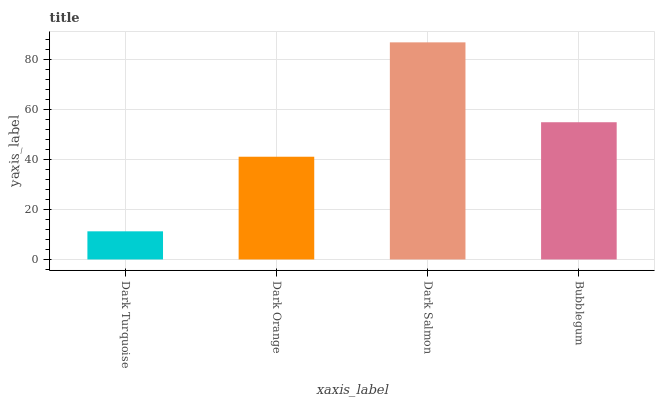Is Dark Turquoise the minimum?
Answer yes or no. Yes. Is Dark Salmon the maximum?
Answer yes or no. Yes. Is Dark Orange the minimum?
Answer yes or no. No. Is Dark Orange the maximum?
Answer yes or no. No. Is Dark Orange greater than Dark Turquoise?
Answer yes or no. Yes. Is Dark Turquoise less than Dark Orange?
Answer yes or no. Yes. Is Dark Turquoise greater than Dark Orange?
Answer yes or no. No. Is Dark Orange less than Dark Turquoise?
Answer yes or no. No. Is Bubblegum the high median?
Answer yes or no. Yes. Is Dark Orange the low median?
Answer yes or no. Yes. Is Dark Turquoise the high median?
Answer yes or no. No. Is Dark Turquoise the low median?
Answer yes or no. No. 